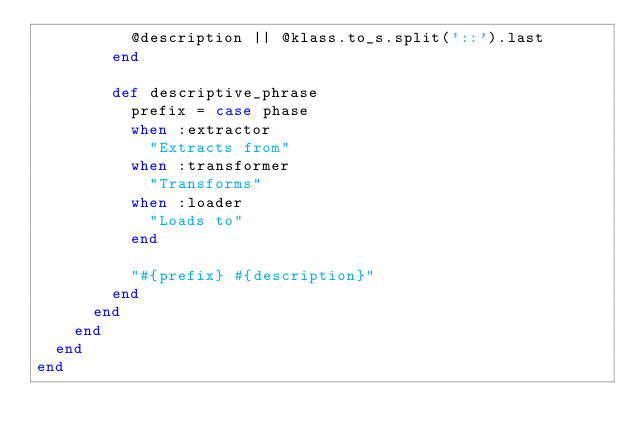Convert code to text. <code><loc_0><loc_0><loc_500><loc_500><_Ruby_>          @description || @klass.to_s.split('::').last
        end

        def descriptive_phrase
          prefix = case phase
          when :extractor
            "Extracts from"
          when :transformer
            "Transforms"
          when :loader
            "Loads to"
          end

          "#{prefix} #{description}"
        end
      end
    end
  end
end
</code> 